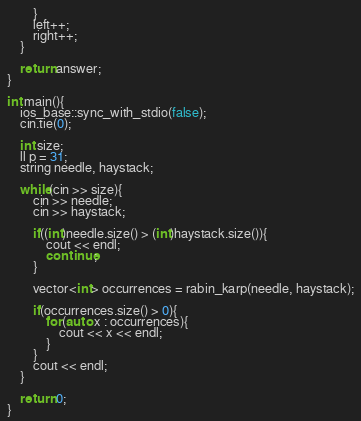<code> <loc_0><loc_0><loc_500><loc_500><_C++_>        }
        left++;
        right++;
    }

    return answer;
}

int main(){
    ios_base::sync_with_stdio(false);
    cin.tie(0);

    int size;
    ll p = 31;
    string needle, haystack;

    while(cin >> size){
        cin >> needle;
        cin >> haystack;

        if((int)needle.size() > (int)haystack.size()){
            cout << endl;
            continue;
        }

        vector<int> occurrences = rabin_karp(needle, haystack);

        if(occurrences.size() > 0){
            for(auto x : occurrences){
                cout << x << endl;
            }
        }
        cout << endl;
    }
    
    return 0;
}
</code> 